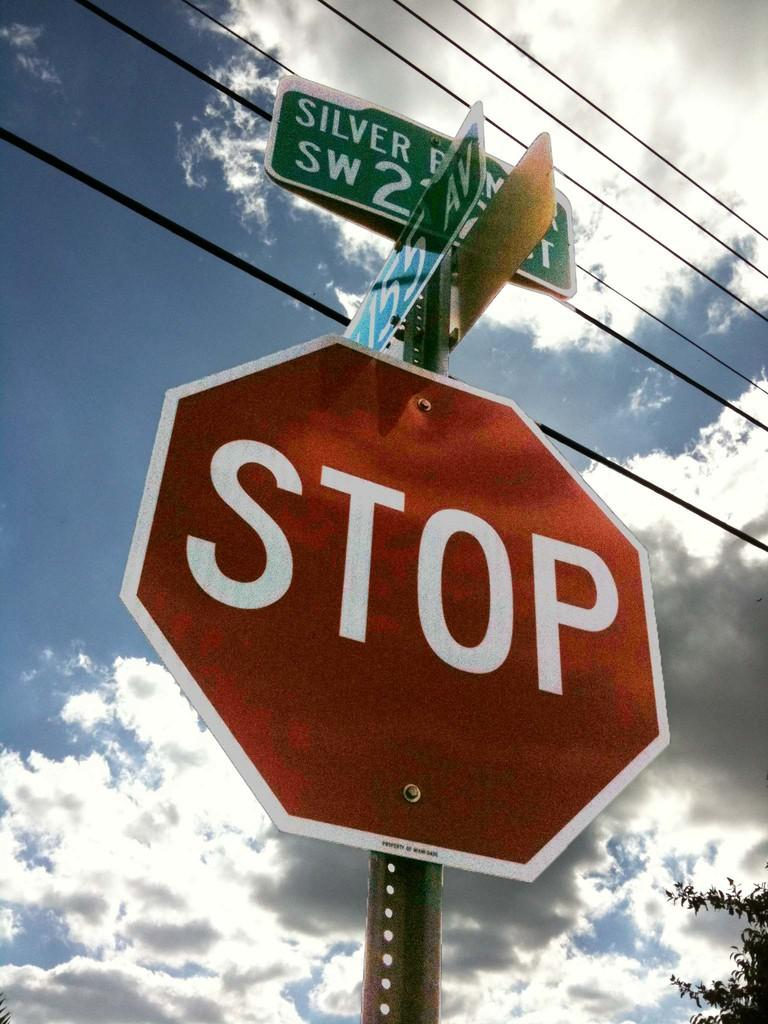<image>
Provide a brief description of the given image. A red STOP sign under a partially cloudy sky 